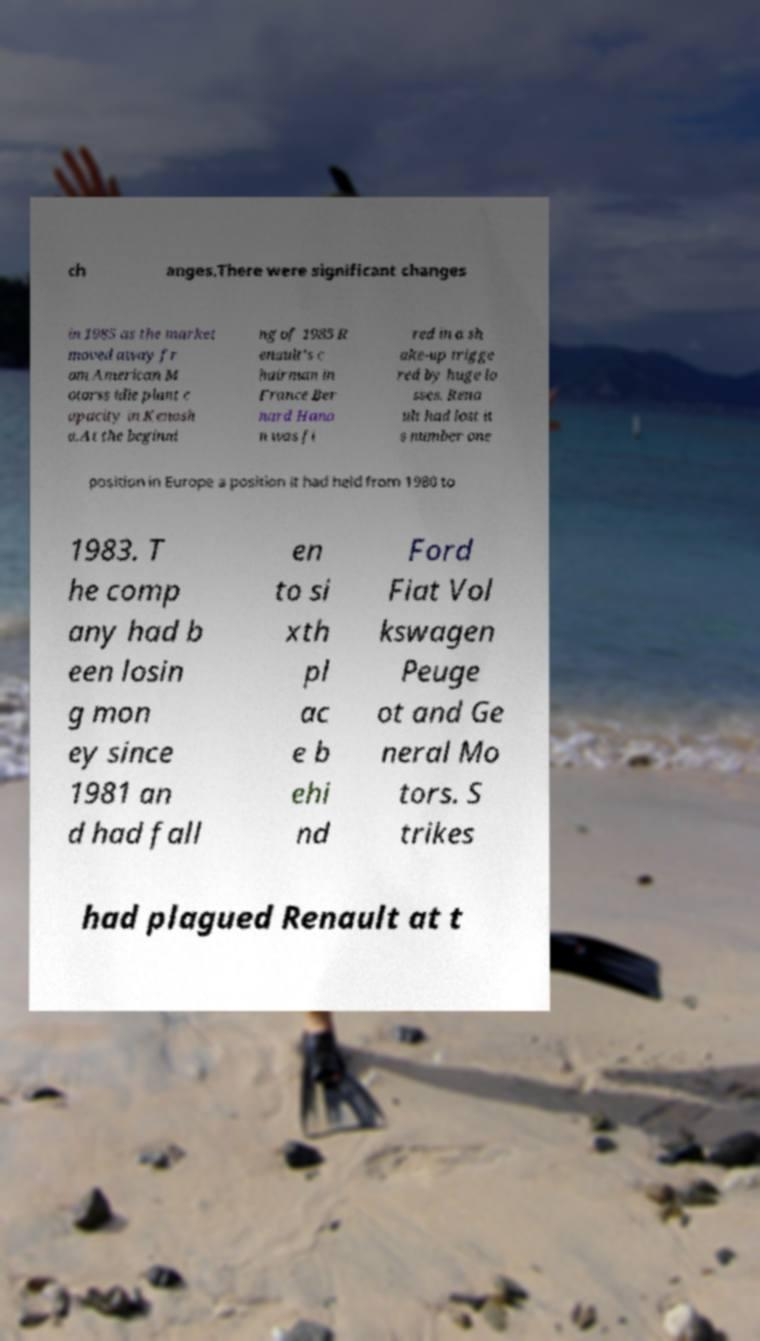There's text embedded in this image that I need extracted. Can you transcribe it verbatim? ch anges.There were significant changes in 1985 as the market moved away fr om American M otorss idle plant c apacity in Kenosh a.At the beginni ng of 1985 R enault's c hairman in France Ber nard Hano n was fi red in a sh ake-up trigge red by huge lo sses. Rena ult had lost it s number one position in Europe a position it had held from 1980 to 1983. T he comp any had b een losin g mon ey since 1981 an d had fall en to si xth pl ac e b ehi nd Ford Fiat Vol kswagen Peuge ot and Ge neral Mo tors. S trikes had plagued Renault at t 